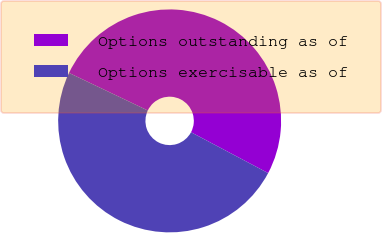<chart> <loc_0><loc_0><loc_500><loc_500><pie_chart><fcel>Options outstanding as of<fcel>Options exercisable as of<nl><fcel>50.67%<fcel>49.33%<nl></chart> 